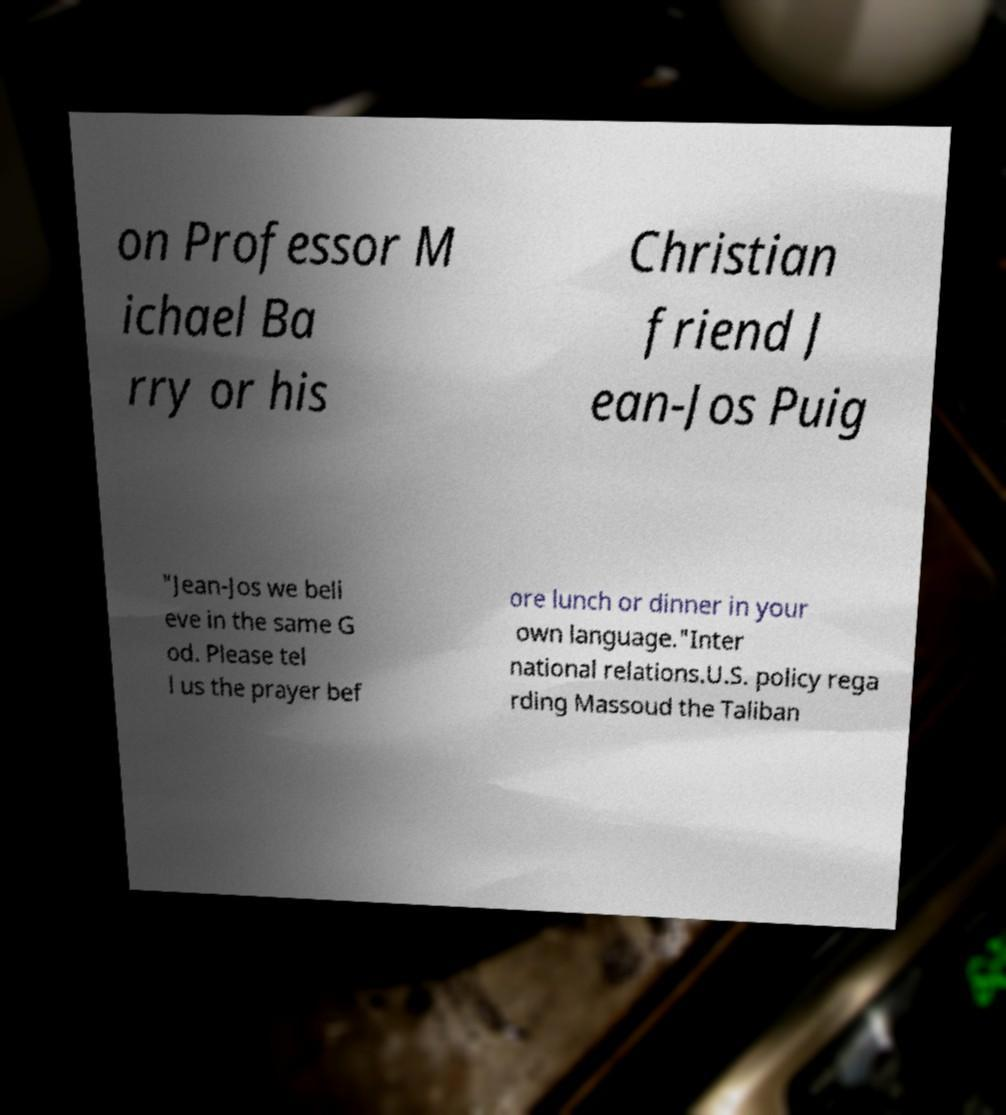Please identify and transcribe the text found in this image. on Professor M ichael Ba rry or his Christian friend J ean-Jos Puig "Jean-Jos we beli eve in the same G od. Please tel l us the prayer bef ore lunch or dinner in your own language."Inter national relations.U.S. policy rega rding Massoud the Taliban 